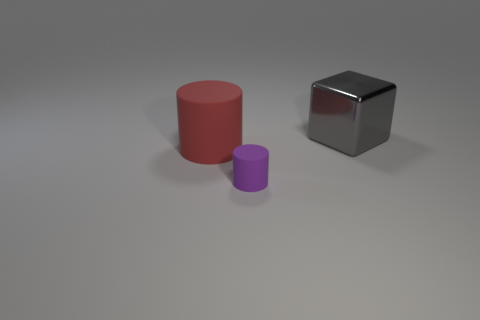What is the shape of the red rubber object?
Provide a short and direct response. Cylinder. There is a purple object; does it have the same shape as the big thing that is to the right of the big red matte cylinder?
Provide a succinct answer. No. There is a matte thing behind the small purple rubber cylinder; is it the same shape as the tiny matte object?
Provide a short and direct response. Yes. What number of things are right of the large red cylinder and in front of the gray metal thing?
Give a very brief answer. 1. What number of other objects are there of the same size as the purple object?
Provide a short and direct response. 0. Is the number of small objects behind the gray metallic thing the same as the number of large yellow matte blocks?
Provide a short and direct response. Yes. There is a object that is behind the purple object and on the right side of the big red rubber cylinder; what material is it?
Make the answer very short. Metal. What is the color of the large cylinder?
Provide a short and direct response. Red. What number of other things are there of the same shape as the big gray thing?
Ensure brevity in your answer.  0. Is the number of small rubber cylinders behind the big gray shiny block the same as the number of tiny matte things to the right of the big cylinder?
Your answer should be very brief. No. 